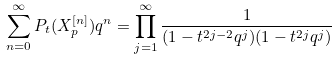Convert formula to latex. <formula><loc_0><loc_0><loc_500><loc_500>\sum _ { n = 0 } ^ { \infty } P _ { t } ( X _ { p } ^ { [ n ] } ) q ^ { n } = \prod _ { j = 1 } ^ { \infty } \frac { 1 } { ( 1 - t ^ { 2 j - 2 } q ^ { j } ) ( 1 - t ^ { 2 j } q ^ { j } ) } \,</formula> 